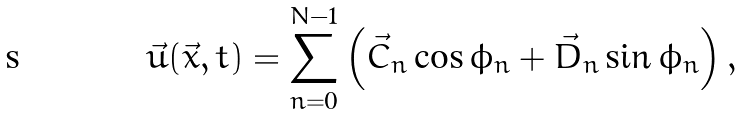Convert formula to latex. <formula><loc_0><loc_0><loc_500><loc_500>\vec { u } ( \vec { x } , t ) = \sum _ { n = 0 } ^ { N - 1 } \left ( \vec { C } _ { n } \cos \phi _ { n } + \vec { D } _ { n } \sin \phi _ { n } \right ) ,</formula> 